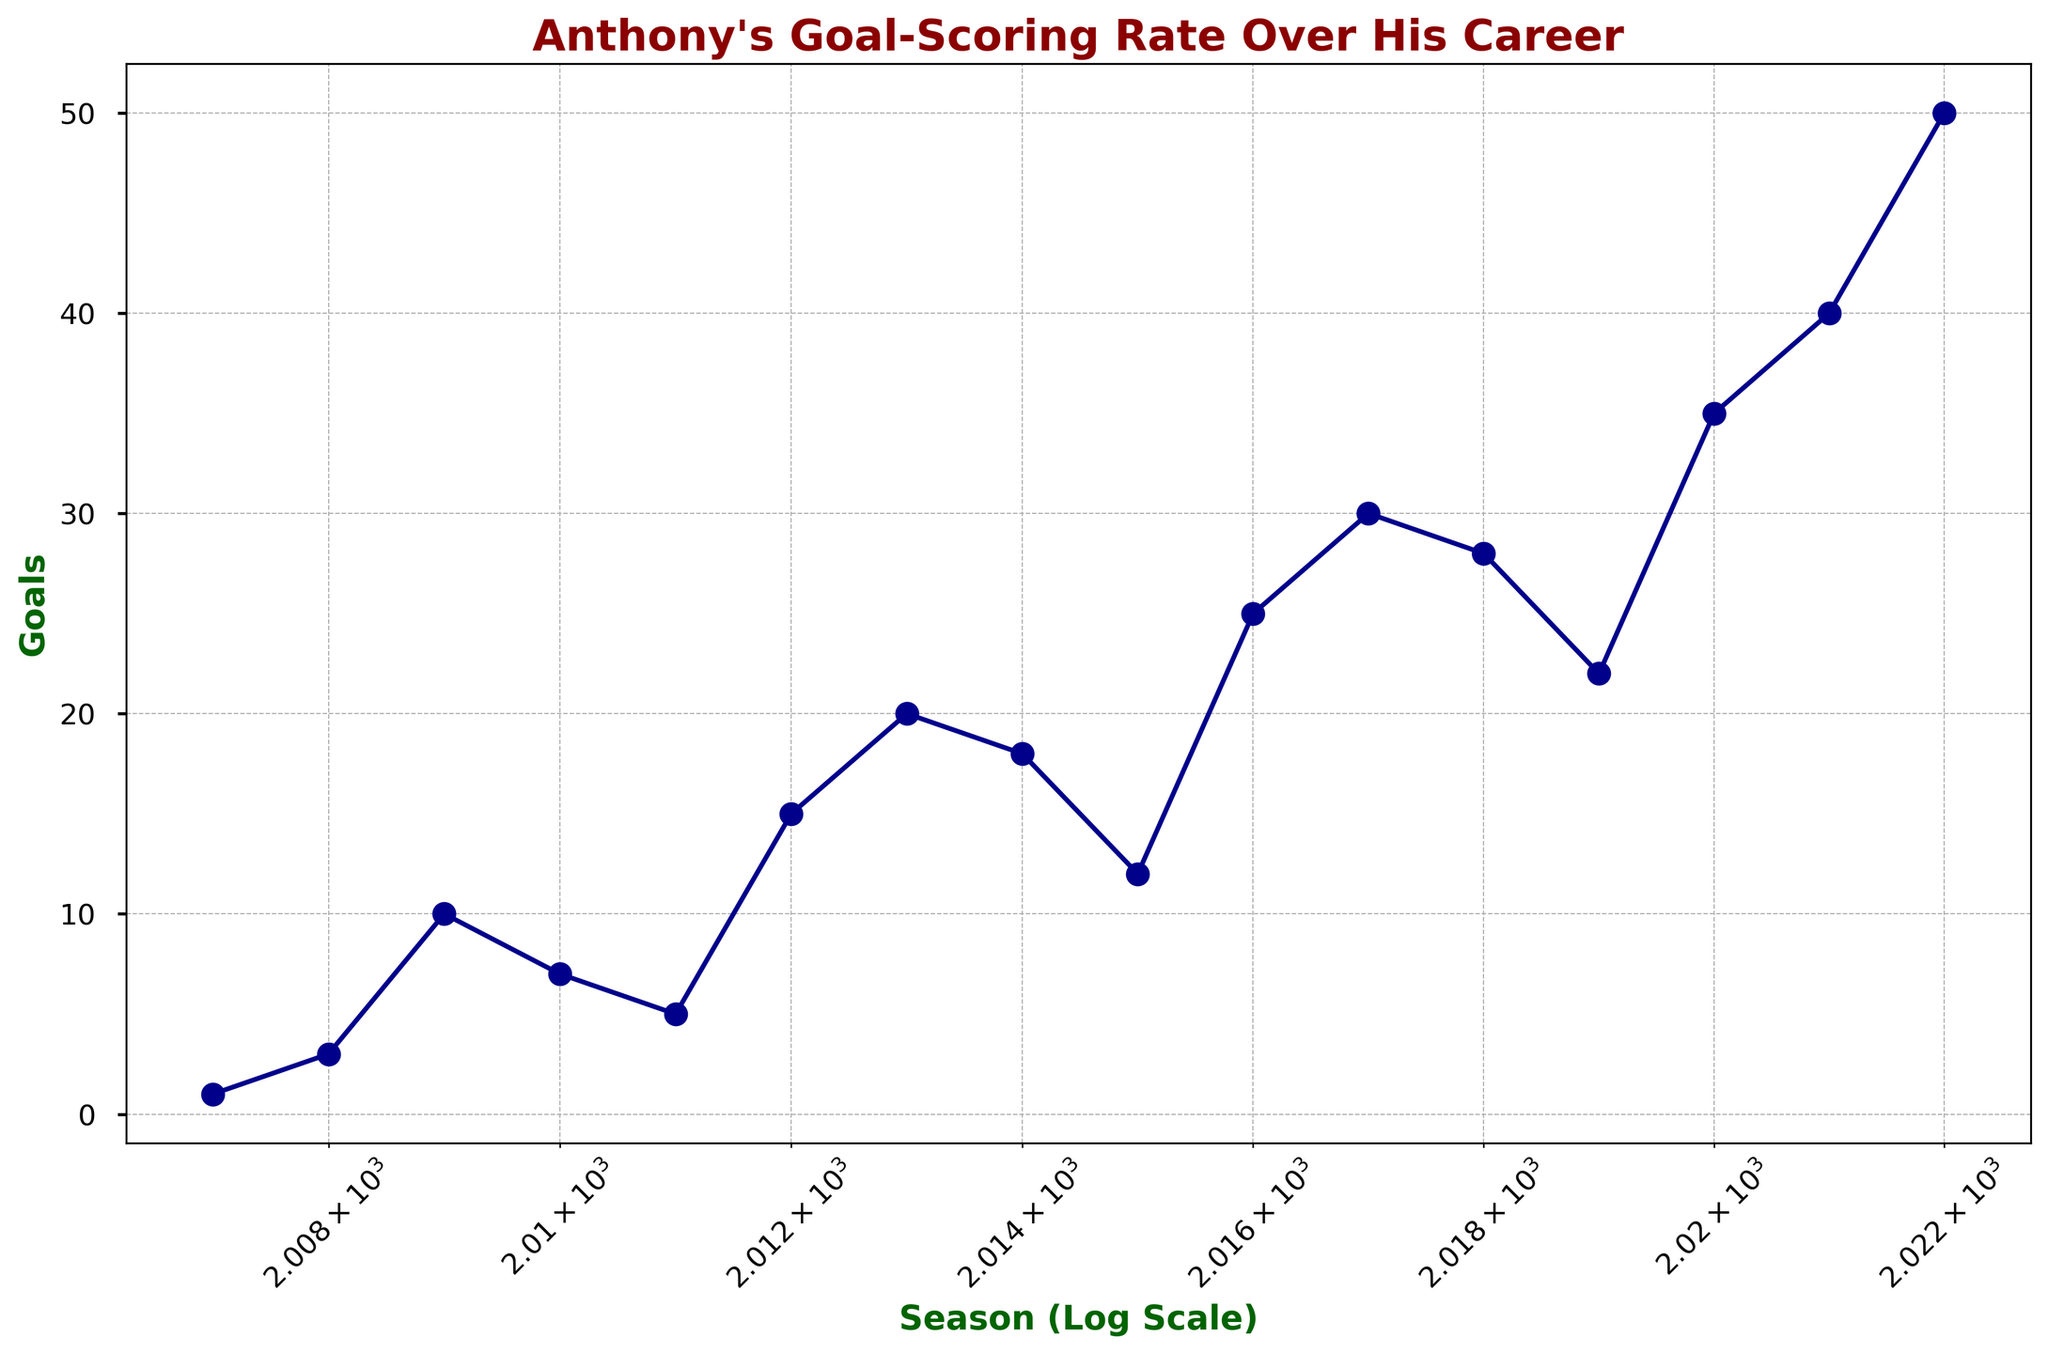What was Anthony's goal-scoring trend from 2010 to 2015? To determine the trend, we observe the goals scored each season from 2010 to 2015. The goals he scored in these seasons were: 7 (2010), 5 (2011), 15 (2012), 20 (2013), 18 (2014), and 12 (2015). While the goal count increased significantly from 2011 to 2013, it started to decrease after 2013. Thus, the trend shows an initial increase followed by a decrease.
Answer: Initial increase, then decrease How many seasons did Anthony score more than 25 goals? To answer this, look for seasons where the goals scored are greater than 25. They are 2017 (30 goals), 2018 (28 goals), 2020 (35 goals), 2021 (40 goals), and 2022 (50 goals). This happens across 5 seasons.
Answer: 5 Which season had the highest goal count, and what was the goal count? The highest point on the plot gives us the maximum goal count. The highest goal count in the plot is 50 goals in the 2022 season.
Answer: 2022, 50 Between which consecutive seasons did Anthony experience the largest increase in goals? We need to compare the differences in goals between consecutive seasons. The highest increase is between 2021 (40 goals) and 2022 (50 goals), an increase of 10 goals.
Answer: 2021 and 2022, 10 goals What was the average number of goals scored per season from 2007 to 2022? To find the average, sum all the goals and divide by the number of seasons (16 seasons). The sum of goals is 341. Average = 341/16 = 21.31.
Answer: 21.31 How did the goal count change from the 2011 season to the 2020 season? The goal count in 2011 was 5, and in 2020, it was 35. The change is 35 - 5 = 30 goals.
Answer: Increased by 30 goals Which season had the smallest number of goals, and what was the goal count? The lowest point on the plot gives us the minimum goal count. The smallest goal count in the plot is 1 goal in the 2007 season.
Answer: 2007, 1 How does the goal-scoring rate compare between the first half (2007-2014) and the second half (2015-2022) of Anthony's career? Calculate the total goals for each half and then compare. First half (2007-2014): 1+3+10+7+5+15+20+18 = 79 goals over 8 seasons. Second half (2015-2022): 12+25+30+28+22+35+40+50 = 242 goals over 8 seasons. Thus, the second half rate is significantly higher.
Answer: Second half is higher What was the median number of goals per season during his career? To find the median, list the goal counts in ascending order: 1, 3, 5, 7, 10, 12, 15, 18, 20, 22, 25, 28, 30, 35, 40, 50. Median is the average of the 8th and 9th values: (18+20)/2 = 19.
Answer: 19 